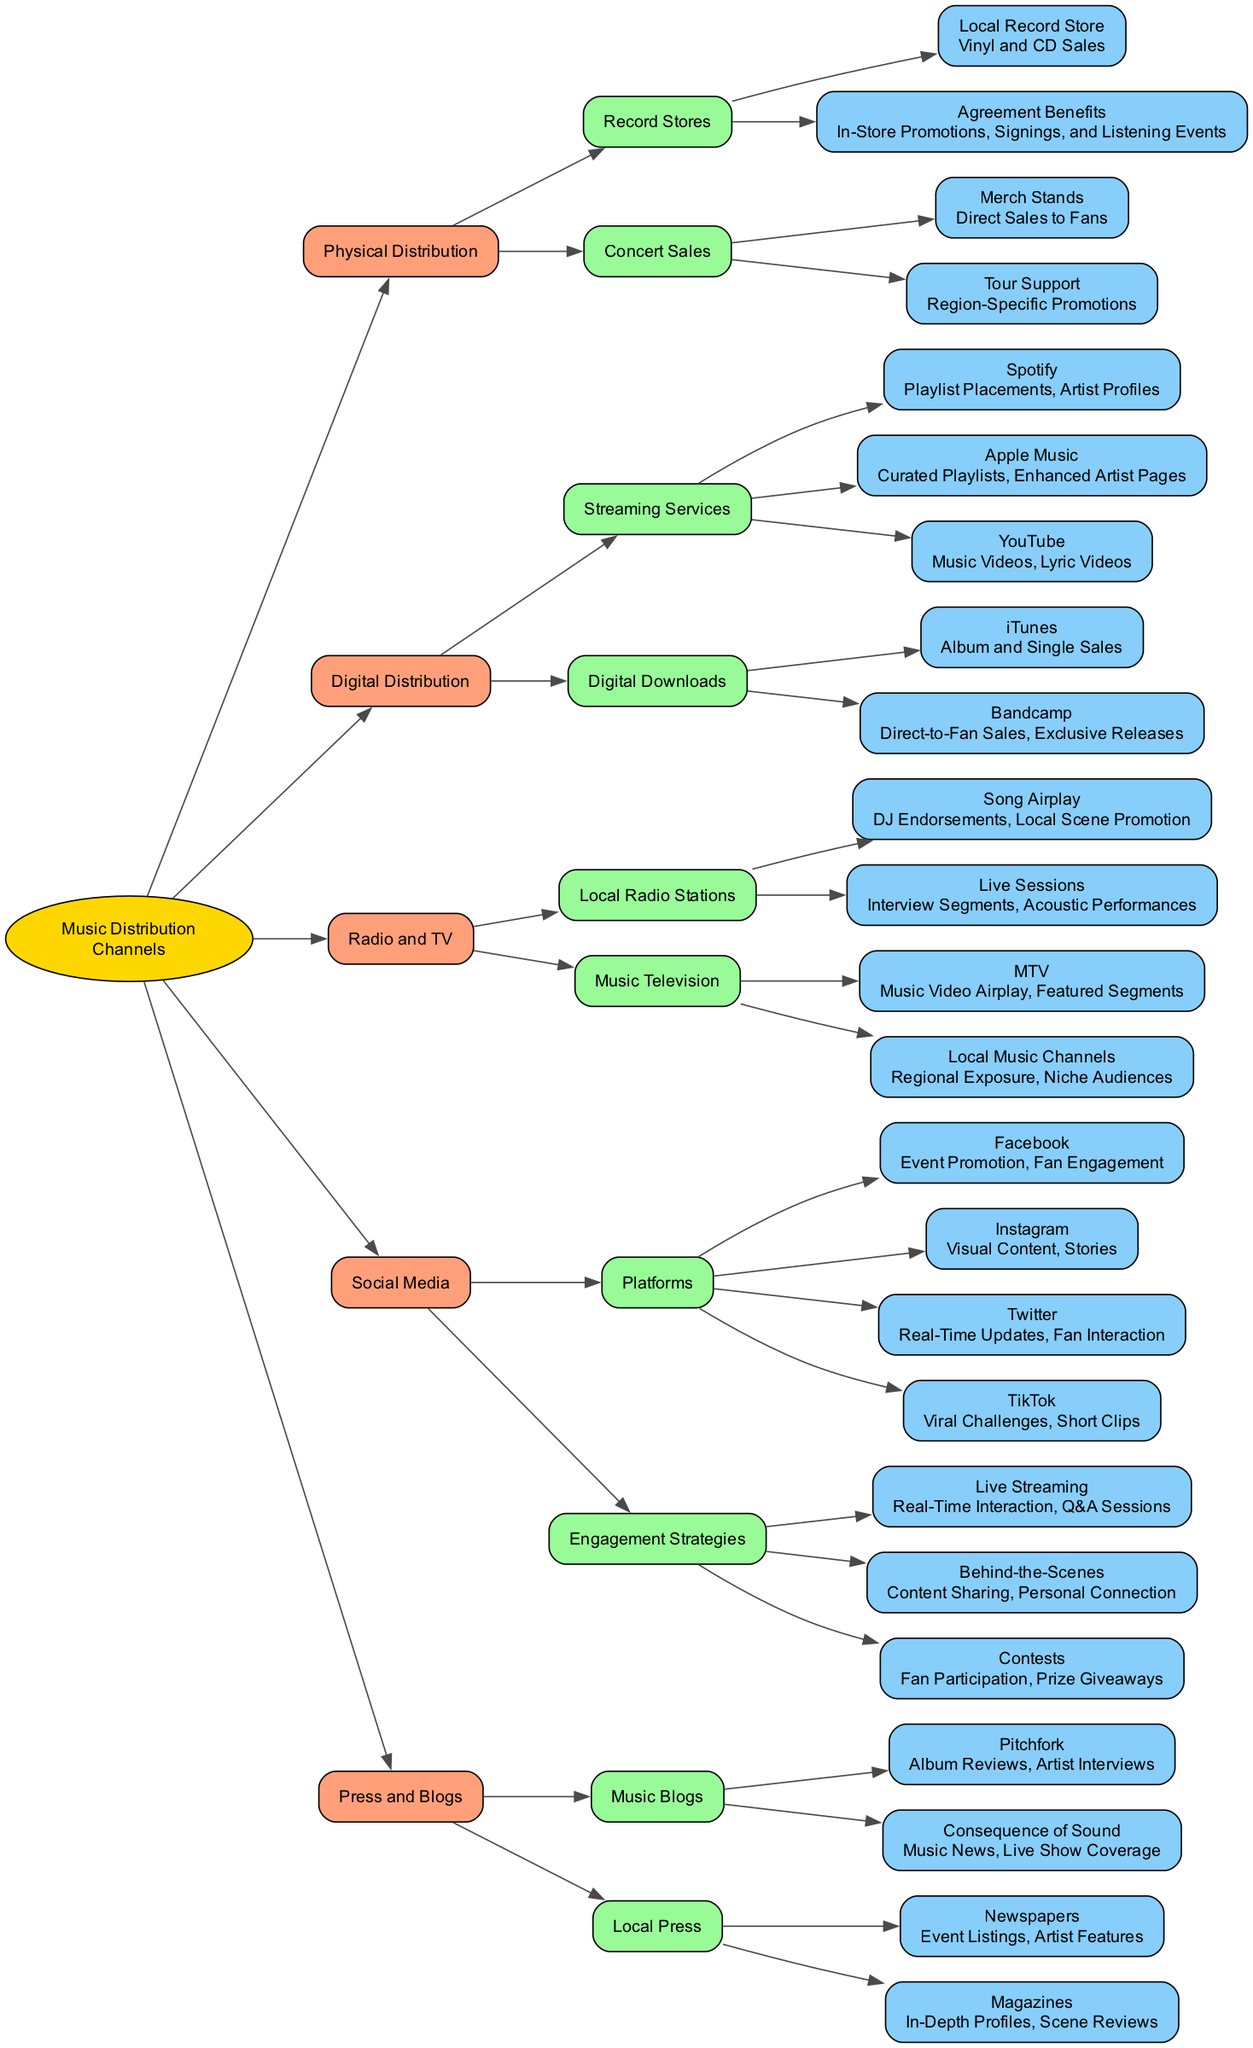What are the two main categories of music distribution channels? The diagram shows two primary branches under "Music Distribution Channels": Physical Distribution and Digital Distribution. These are the two main categories represented in the visual.
Answer: Physical Distribution, Digital Distribution How many streaming services are listed under digital distribution? The digital distribution section includes three streaming services: Spotify, Apple Music, and YouTube. By counting these services, we determine that there are three.
Answer: 3 What benefits do local record stores provide for agreements? The diagram specifies that agreement benefits with local record stores include In-Store Promotions, Signings, and Listening Events. These promotional activities serve to enhance visibility for the musician.
Answer: In-Store Promotions, Signings, and Listening Events Which social media platform is associated with viral challenges? Within the social media section, TikTok is the platform highlighted for its association with viral challenges. This points to its unique role in music promotion compared to other platforms.
Answer: TikTok What is the purpose of live sessions on local radio stations? The diagram indicates that live sessions on local radio stations focus on Interview Segments and Acoustic Performances. These activities aim to engage listeners more intimately and showcase the artist's talent.
Answer: Interview Segments, Acoustic Performances How are artist profiles utilized on streaming services? According to the diagram, artist profiles on Spotify provide Playlist Placements and feature Artist Profiles, which are tools for promotion, helping artists reach wider audiences.
Answer: Playlist Placements, Artist Profiles What type of content does Instagram primarily focus on for music promotion? The diagram illustrates that Instagram emphasizes Visual Content and Stories. This suggests that the platform is leveraged for its visual engagement in promoting music.
Answer: Visual Content, Stories Which music blog provides album reviews? The diagram specifically notes Pitchfork as a music blog that provides Album Reviews, pointing to its role in the critical landscape of music journalism.
Answer: Pitchfork What kind of sales does Bandcamp facilitate? Bandcamp is mentioned in the digital downloads section as facilitating Direct-to-Fan Sales and Exclusive Releases. This highlights its unique position in enabling close artist-to-fan relationships.
Answer: Direct-to-Fan Sales, Exclusive Releases 